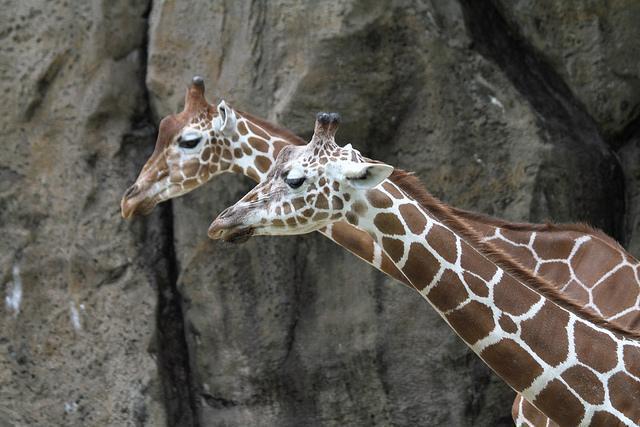How many giraffes are there?
Give a very brief answer. 2. 